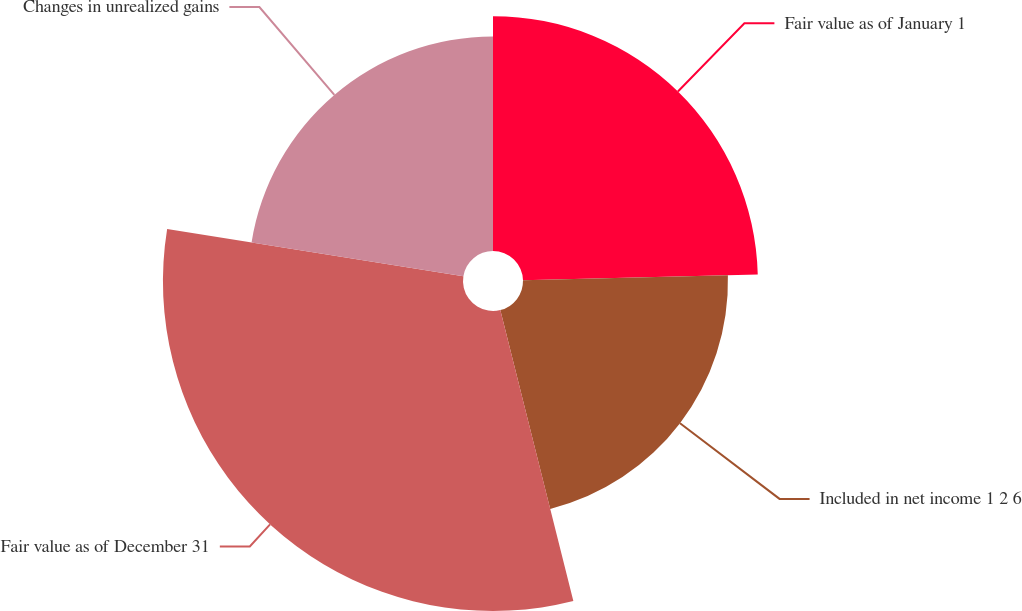<chart> <loc_0><loc_0><loc_500><loc_500><pie_chart><fcel>Fair value as of January 1<fcel>Included in net income 1 2 6<fcel>Fair value as of December 31<fcel>Changes in unrealized gains<nl><fcel>24.61%<fcel>21.48%<fcel>31.44%<fcel>22.48%<nl></chart> 